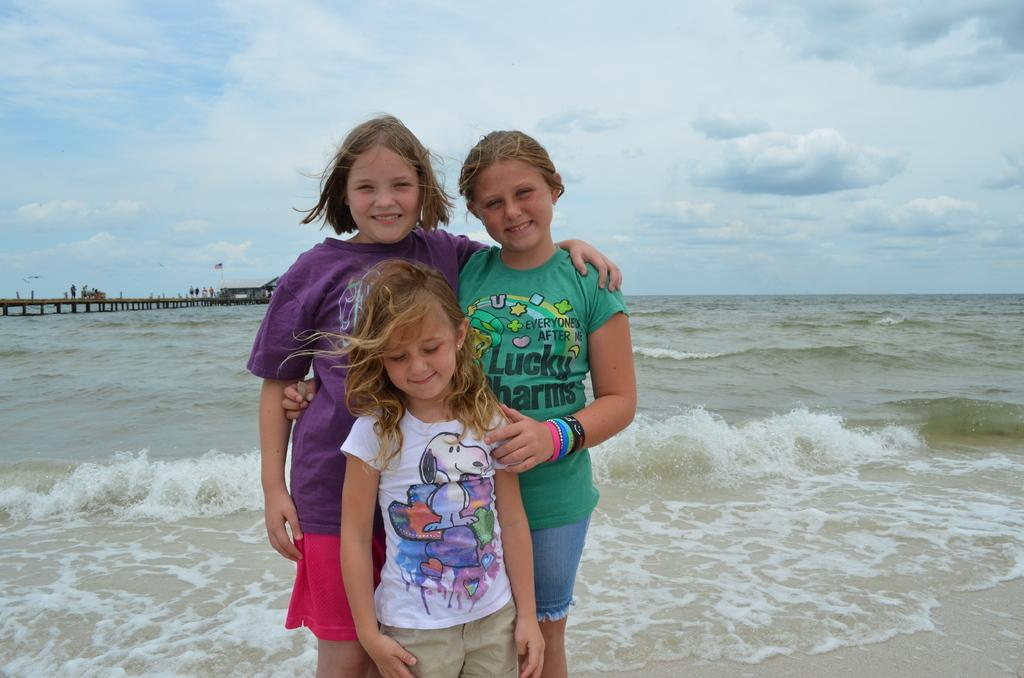What is happening in the image? There are people standing in the image. What can be seen in the background of the image? There is water, a bridge, and other people visible in the background of the image. What is visible at the top of the image? The sky is visible at the top of the image. What can be observed in the sky? There are clouds in the sky. What type of meal is being prepared by the fireman in the image? There is no fireman or meal preparation present in the image. What are the people in the image talking about? The conversation does not mention any talking or dialogue between the people in the image. 